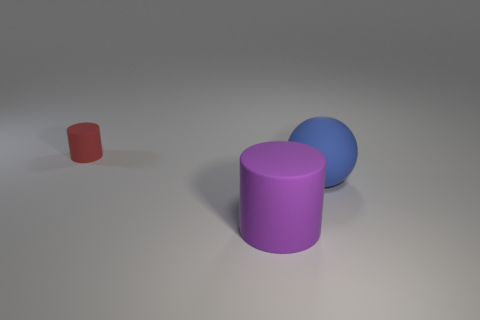Is the size of the blue sphere the same as the object in front of the blue thing?
Provide a succinct answer. Yes. The big rubber cylinder has what color?
Offer a very short reply. Purple. There is a large object behind the cylinder that is right of the matte cylinder behind the blue matte sphere; what is its shape?
Ensure brevity in your answer.  Sphere. There is a big thing behind the rubber cylinder that is in front of the small red matte cylinder; what is its material?
Your answer should be compact. Rubber. What is the shape of the large purple object that is made of the same material as the tiny cylinder?
Make the answer very short. Cylinder. Is there any other thing that is the same shape as the blue thing?
Give a very brief answer. No. How many matte balls are on the left side of the red rubber object?
Ensure brevity in your answer.  0. Is there a big cyan matte cylinder?
Offer a terse response. No. There is a rubber cylinder that is behind the object that is right of the large object that is on the left side of the blue sphere; what color is it?
Your response must be concise. Red. Are there any cylinders that are in front of the cylinder that is left of the purple matte object?
Offer a terse response. Yes. 